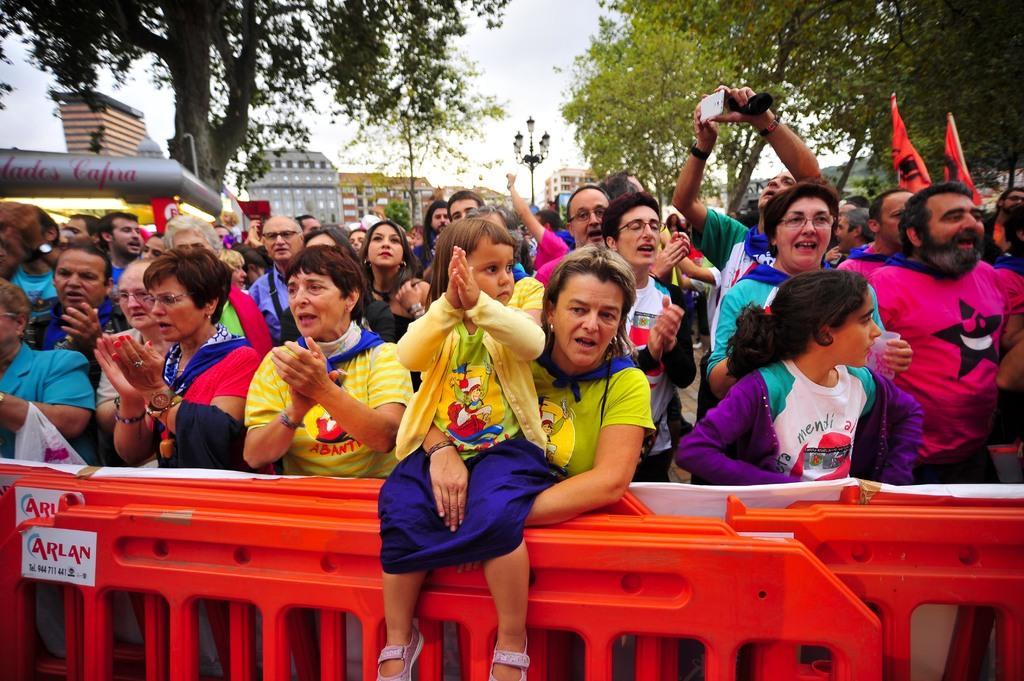How would you summarize this image in a sentence or two? In this image I can see a crowd, at the bottom there is a orange color fence, at the top there are some trees, street light poles, buildings and the sky visible. And a vehicle visible on the left side 